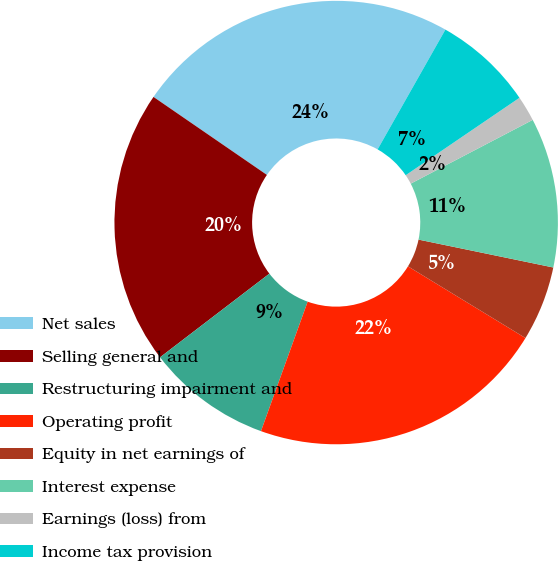<chart> <loc_0><loc_0><loc_500><loc_500><pie_chart><fcel>Net sales<fcel>Selling general and<fcel>Restructuring impairment and<fcel>Operating profit<fcel>Equity in net earnings of<fcel>Interest expense<fcel>Earnings (loss) from<fcel>Income tax provision<nl><fcel>23.61%<fcel>19.98%<fcel>9.1%<fcel>21.79%<fcel>5.47%<fcel>10.91%<fcel>1.85%<fcel>7.29%<nl></chart> 